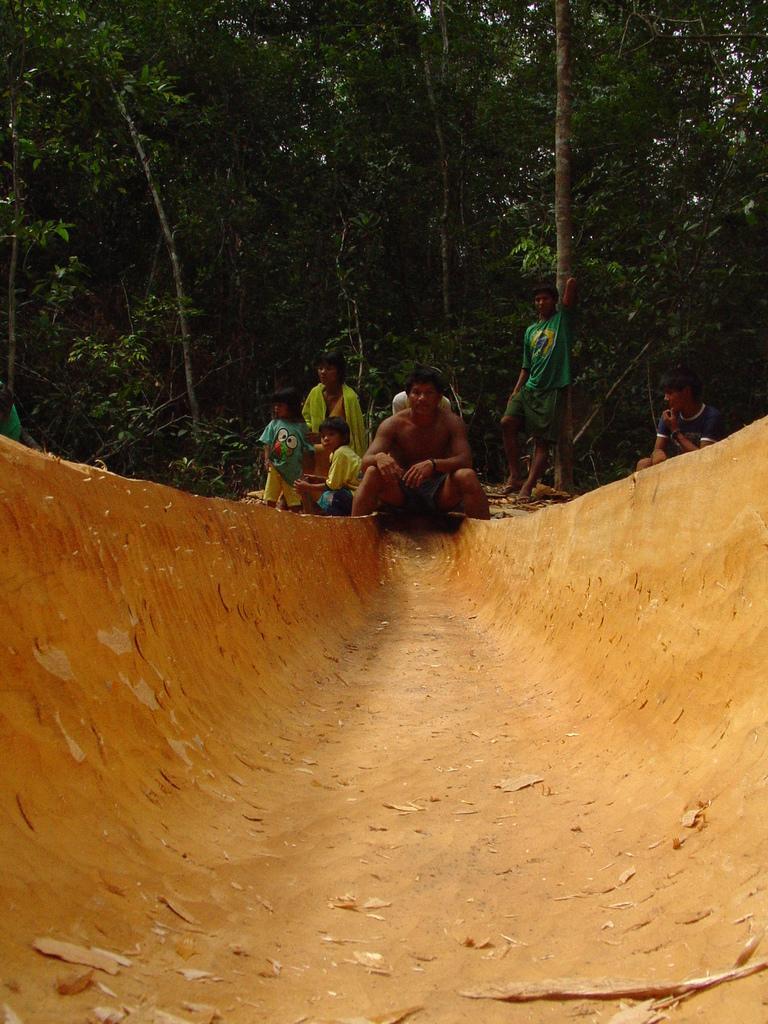Describe this image in one or two sentences. In the picture we can see a muddy tunnel and on it we can see a man sitting and beside him we can see a two kids and a woman and behind them we can see full of trees. 